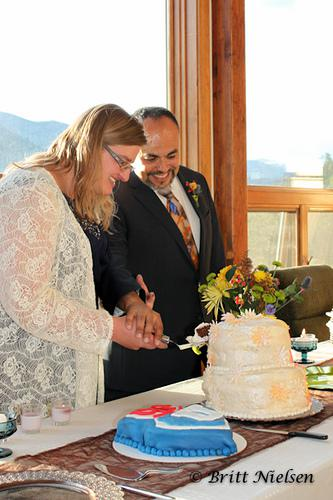Question: who is wearing glasses?
Choices:
A. The man.
B. The boy.
C. The woman.
D. The girl.
Answer with the letter. Answer: C Question: what is the couple doing?
Choices:
A. Kissing.
B. Holding hands.
C. Sharing an umbrella.
D. Cutting the cake.
Answer with the letter. Answer: D Question: how is the couple feeling?
Choices:
A. Very sad.
B. Very bored.
C. Very tired.
D. Very happy.
Answer with the letter. Answer: D Question: what color is the wedding cake?
Choices:
A. White.
B. Blue.
C. Black.
D. White and orange.
Answer with the letter. Answer: D Question: what color suit is the groom wearing?
Choices:
A. Blue.
B. Grey.
C. Black.
D. White.
Answer with the letter. Answer: C Question: when was this picture taken?
Choices:
A. During the early morning.
B. At night.
C. During the daytime.
D. In the evening.
Answer with the letter. Answer: C 